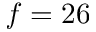Convert formula to latex. <formula><loc_0><loc_0><loc_500><loc_500>f = 2 6</formula> 